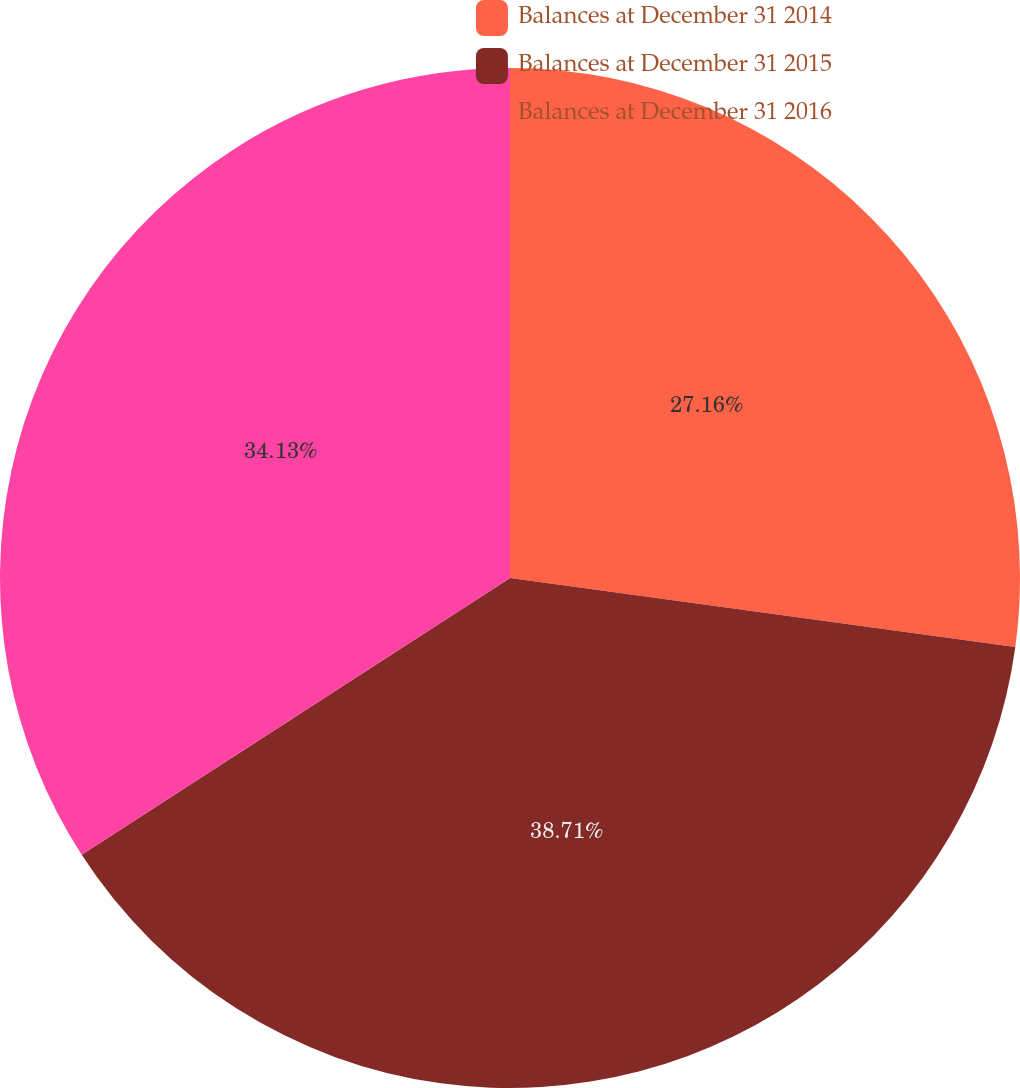<chart> <loc_0><loc_0><loc_500><loc_500><pie_chart><fcel>Balances at December 31 2014<fcel>Balances at December 31 2015<fcel>Balances at December 31 2016<nl><fcel>27.16%<fcel>38.7%<fcel>34.13%<nl></chart> 